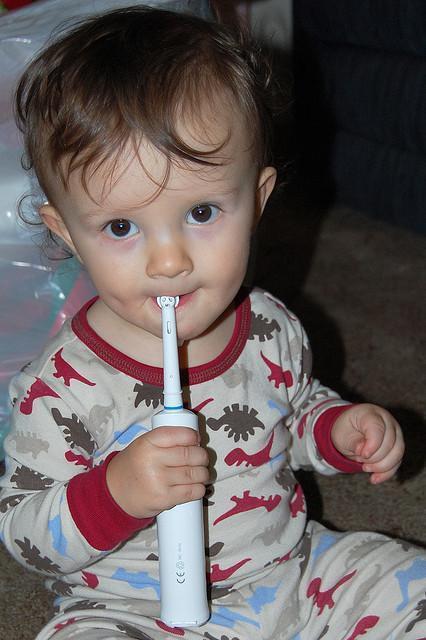How many toothbrushes are there?
Give a very brief answer. 1. 